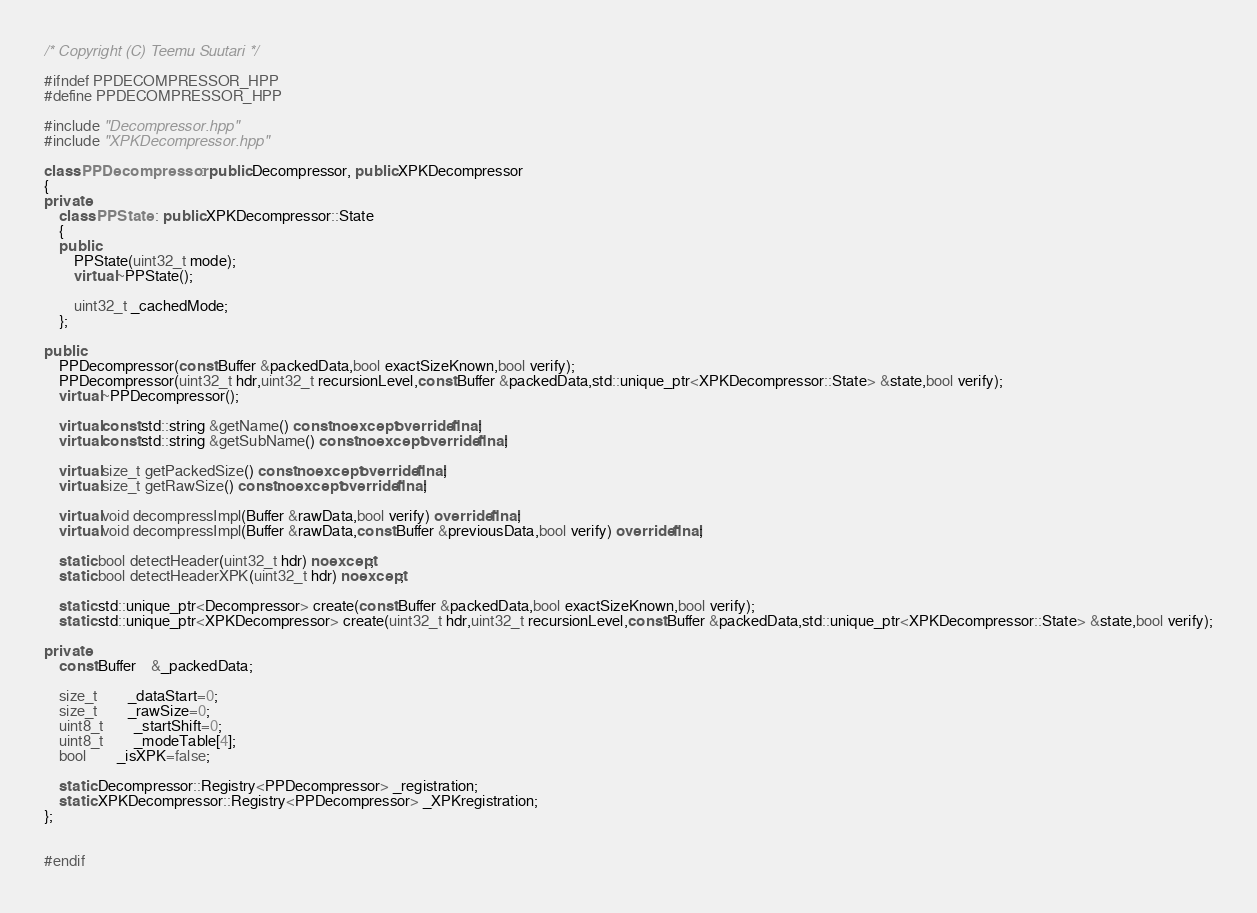<code> <loc_0><loc_0><loc_500><loc_500><_C++_>/* Copyright (C) Teemu Suutari */

#ifndef PPDECOMPRESSOR_HPP
#define PPDECOMPRESSOR_HPP

#include "Decompressor.hpp"
#include "XPKDecompressor.hpp"

class PPDecompressor : public Decompressor, public XPKDecompressor
{
private:
	class PPState : public XPKDecompressor::State
	{
	public:
		PPState(uint32_t mode);
		virtual ~PPState();

		uint32_t _cachedMode;
	};

public:
	PPDecompressor(const Buffer &packedData,bool exactSizeKnown,bool verify);
	PPDecompressor(uint32_t hdr,uint32_t recursionLevel,const Buffer &packedData,std::unique_ptr<XPKDecompressor::State> &state,bool verify);
	virtual ~PPDecompressor();

	virtual const std::string &getName() const noexcept override final;
	virtual const std::string &getSubName() const noexcept override final;

	virtual size_t getPackedSize() const noexcept override final;
	virtual size_t getRawSize() const noexcept override final;

	virtual void decompressImpl(Buffer &rawData,bool verify) override final;
	virtual void decompressImpl(Buffer &rawData,const Buffer &previousData,bool verify) override final;

	static bool detectHeader(uint32_t hdr) noexcept;
	static bool detectHeaderXPK(uint32_t hdr) noexcept;

	static std::unique_ptr<Decompressor> create(const Buffer &packedData,bool exactSizeKnown,bool verify);
	static std::unique_ptr<XPKDecompressor> create(uint32_t hdr,uint32_t recursionLevel,const Buffer &packedData,std::unique_ptr<XPKDecompressor::State> &state,bool verify);

private:
	const Buffer	&_packedData;

	size_t		_dataStart=0;
	size_t		_rawSize=0;
	uint8_t		_startShift=0;
	uint8_t		_modeTable[4];
	bool		_isXPK=false;

	static Decompressor::Registry<PPDecompressor> _registration;
	static XPKDecompressor::Registry<PPDecompressor> _XPKregistration;
};


#endif
</code> 